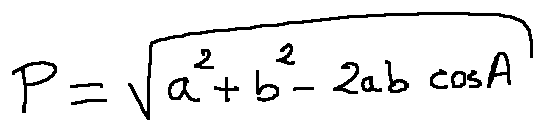<formula> <loc_0><loc_0><loc_500><loc_500>p = \sqrt { a ^ { 2 } + b ^ { 2 } - 2 a b \cos A }</formula> 